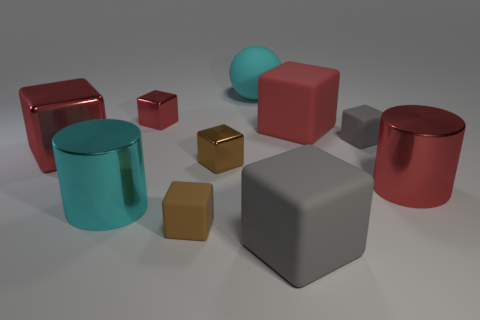There is another large cube that is the same color as the big metallic cube; what is its material?
Make the answer very short. Rubber. How many other things are the same material as the large gray thing?
Ensure brevity in your answer.  4. Are there an equal number of rubber blocks that are on the right side of the cyan ball and small objects that are behind the red metallic cylinder?
Ensure brevity in your answer.  Yes. The metal cylinder that is left of the small brown block behind the red shiny thing that is right of the big red matte thing is what color?
Offer a very short reply. Cyan. There is a big red metallic object left of the big cyan cylinder; what shape is it?
Offer a terse response. Cube. There is a cyan thing that is made of the same material as the tiny gray cube; what shape is it?
Ensure brevity in your answer.  Sphere. Is there anything else that has the same shape as the cyan matte object?
Offer a very short reply. No. There is a small brown metal cube; what number of small brown metal objects are behind it?
Your answer should be very brief. 0. Is the number of big cubes that are in front of the large red rubber cube the same as the number of red metallic cubes?
Offer a terse response. Yes. Is the big cyan cylinder made of the same material as the big gray cube?
Make the answer very short. No. 